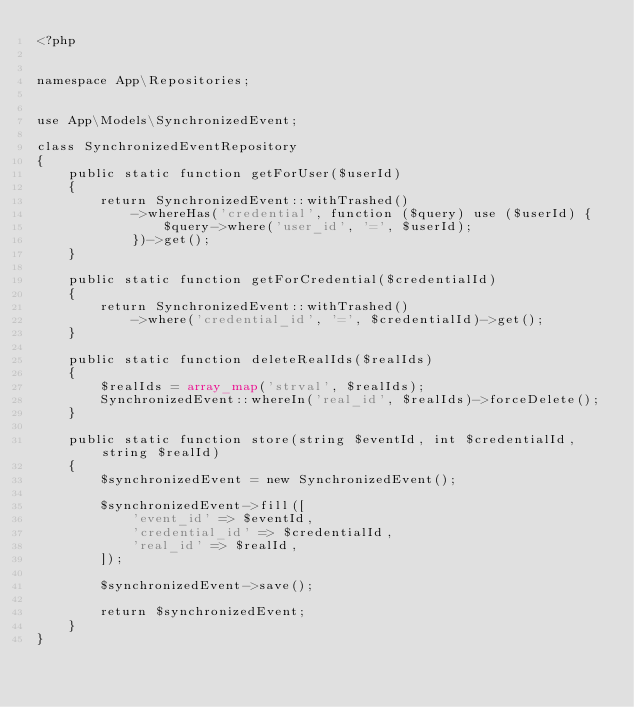<code> <loc_0><loc_0><loc_500><loc_500><_PHP_><?php


namespace App\Repositories;


use App\Models\SynchronizedEvent;

class SynchronizedEventRepository
{
    public static function getForUser($userId)
    {
        return SynchronizedEvent::withTrashed()
            ->whereHas('credential', function ($query) use ($userId) {
                $query->where('user_id', '=', $userId);
            })->get();
    }

    public static function getForCredential($credentialId)
    {
        return SynchronizedEvent::withTrashed()
            ->where('credential_id', '=', $credentialId)->get();
    }

    public static function deleteRealIds($realIds)
    {
        $realIds = array_map('strval', $realIds);
        SynchronizedEvent::whereIn('real_id', $realIds)->forceDelete();
    }

    public static function store(string $eventId, int $credentialId, string $realId)
    {
        $synchronizedEvent = new SynchronizedEvent();

        $synchronizedEvent->fill([
            'event_id' => $eventId,
            'credential_id' => $credentialId,
            'real_id' => $realId,
        ]);

        $synchronizedEvent->save();

        return $synchronizedEvent;
    }
}
</code> 